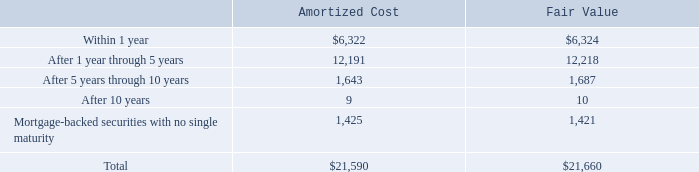The following table summarizes the maturities of our available-for-sale debt investments as of July 27, 2019 (in millions):
Actual maturities may differ from the contractual maturities because borrowers may have the right to call or prepay certain obligations.
Why would actual maturities differ from the contractual maturities? Borrowers may have the right to call or prepay certain obligations. What was the amortized cost for available-for-sale debt investments  within 1 year?
Answer scale should be: million. 6,322. What was the fair value of debt investments that had maturities after 1 year through 5 years?
Answer scale should be: million. 12,218. What was the fair value of debt investments that had maturities within 1 year as a percentage of the total?
Answer scale should be: percent. 6,324/21,660
Answer: 29.2. What was the difference between the amortized cost of debt investments that were within 1 year and after 1 year through 5 years?
Answer scale should be: million. 12,191-6,322
Answer: 5869. What was the difference between the total amortized cost and total fair value?
Answer scale should be: million. 21,660-21,590
Answer: 70. 